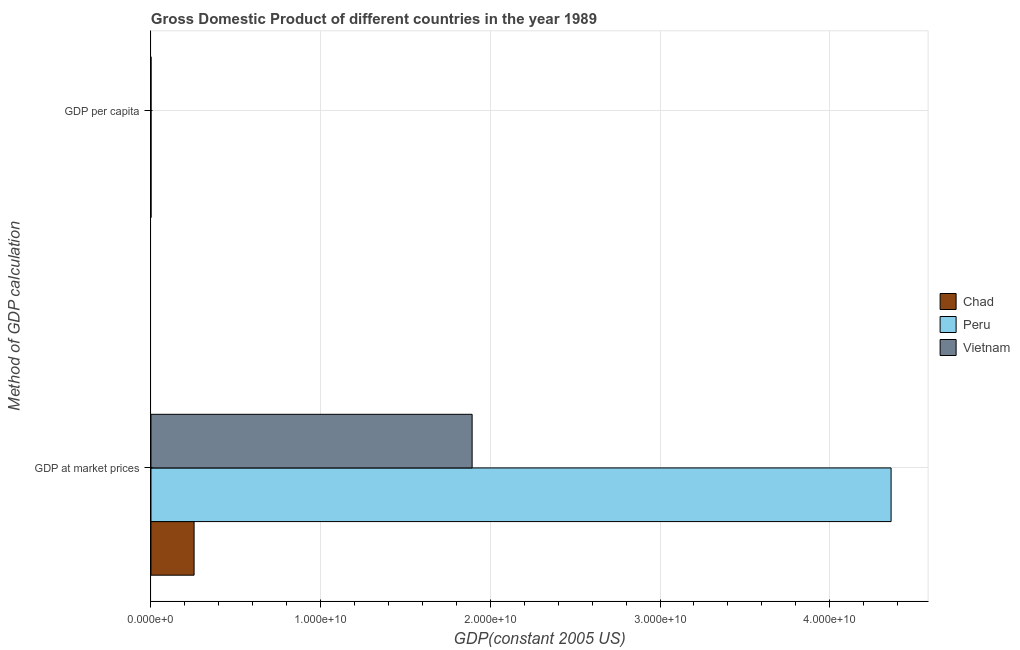How many different coloured bars are there?
Your answer should be compact. 3. Are the number of bars per tick equal to the number of legend labels?
Provide a short and direct response. Yes. What is the label of the 2nd group of bars from the top?
Offer a very short reply. GDP at market prices. What is the gdp per capita in Peru?
Your answer should be very brief. 2041.08. Across all countries, what is the maximum gdp per capita?
Offer a terse response. 2041.08. Across all countries, what is the minimum gdp at market prices?
Keep it short and to the point. 2.54e+09. In which country was the gdp per capita maximum?
Keep it short and to the point. Peru. In which country was the gdp per capita minimum?
Offer a very short reply. Vietnam. What is the total gdp at market prices in the graph?
Your answer should be compact. 6.51e+1. What is the difference between the gdp per capita in Chad and that in Vietnam?
Provide a short and direct response. 148.32. What is the difference between the gdp at market prices in Chad and the gdp per capita in Peru?
Provide a succinct answer. 2.54e+09. What is the average gdp at market prices per country?
Ensure brevity in your answer.  2.17e+1. What is the difference between the gdp per capita and gdp at market prices in Chad?
Provide a short and direct response. -2.54e+09. What is the ratio of the gdp per capita in Peru to that in Vietnam?
Offer a very short reply. 6.99. Is the gdp per capita in Vietnam less than that in Chad?
Provide a succinct answer. Yes. What does the 3rd bar from the top in GDP per capita represents?
Keep it short and to the point. Chad. What does the 3rd bar from the bottom in GDP per capita represents?
Keep it short and to the point. Vietnam. How many bars are there?
Give a very brief answer. 6. How many countries are there in the graph?
Your answer should be very brief. 3. What is the difference between two consecutive major ticks on the X-axis?
Provide a short and direct response. 1.00e+1. Are the values on the major ticks of X-axis written in scientific E-notation?
Keep it short and to the point. Yes. Does the graph contain any zero values?
Keep it short and to the point. No. Does the graph contain grids?
Ensure brevity in your answer.  Yes. Where does the legend appear in the graph?
Provide a succinct answer. Center right. How many legend labels are there?
Your answer should be compact. 3. What is the title of the graph?
Your answer should be very brief. Gross Domestic Product of different countries in the year 1989. What is the label or title of the X-axis?
Offer a very short reply. GDP(constant 2005 US). What is the label or title of the Y-axis?
Provide a short and direct response. Method of GDP calculation. What is the GDP(constant 2005 US) of Chad in GDP at market prices?
Your answer should be compact. 2.54e+09. What is the GDP(constant 2005 US) in Peru in GDP at market prices?
Offer a terse response. 4.36e+1. What is the GDP(constant 2005 US) in Vietnam in GDP at market prices?
Your response must be concise. 1.89e+1. What is the GDP(constant 2005 US) of Chad in GDP per capita?
Provide a succinct answer. 440.51. What is the GDP(constant 2005 US) of Peru in GDP per capita?
Provide a short and direct response. 2041.08. What is the GDP(constant 2005 US) of Vietnam in GDP per capita?
Your answer should be compact. 292.19. Across all Method of GDP calculation, what is the maximum GDP(constant 2005 US) of Chad?
Provide a short and direct response. 2.54e+09. Across all Method of GDP calculation, what is the maximum GDP(constant 2005 US) of Peru?
Your answer should be compact. 4.36e+1. Across all Method of GDP calculation, what is the maximum GDP(constant 2005 US) of Vietnam?
Make the answer very short. 1.89e+1. Across all Method of GDP calculation, what is the minimum GDP(constant 2005 US) in Chad?
Provide a succinct answer. 440.51. Across all Method of GDP calculation, what is the minimum GDP(constant 2005 US) in Peru?
Offer a very short reply. 2041.08. Across all Method of GDP calculation, what is the minimum GDP(constant 2005 US) of Vietnam?
Make the answer very short. 292.19. What is the total GDP(constant 2005 US) of Chad in the graph?
Your response must be concise. 2.54e+09. What is the total GDP(constant 2005 US) in Peru in the graph?
Ensure brevity in your answer.  4.36e+1. What is the total GDP(constant 2005 US) of Vietnam in the graph?
Your response must be concise. 1.89e+1. What is the difference between the GDP(constant 2005 US) of Chad in GDP at market prices and that in GDP per capita?
Make the answer very short. 2.54e+09. What is the difference between the GDP(constant 2005 US) in Peru in GDP at market prices and that in GDP per capita?
Provide a short and direct response. 4.36e+1. What is the difference between the GDP(constant 2005 US) of Vietnam in GDP at market prices and that in GDP per capita?
Your answer should be compact. 1.89e+1. What is the difference between the GDP(constant 2005 US) of Chad in GDP at market prices and the GDP(constant 2005 US) of Peru in GDP per capita?
Your answer should be very brief. 2.54e+09. What is the difference between the GDP(constant 2005 US) in Chad in GDP at market prices and the GDP(constant 2005 US) in Vietnam in GDP per capita?
Your answer should be very brief. 2.54e+09. What is the difference between the GDP(constant 2005 US) in Peru in GDP at market prices and the GDP(constant 2005 US) in Vietnam in GDP per capita?
Offer a very short reply. 4.36e+1. What is the average GDP(constant 2005 US) in Chad per Method of GDP calculation?
Offer a terse response. 1.27e+09. What is the average GDP(constant 2005 US) of Peru per Method of GDP calculation?
Your answer should be compact. 2.18e+1. What is the average GDP(constant 2005 US) in Vietnam per Method of GDP calculation?
Your answer should be compact. 9.46e+09. What is the difference between the GDP(constant 2005 US) of Chad and GDP(constant 2005 US) of Peru in GDP at market prices?
Provide a short and direct response. -4.11e+1. What is the difference between the GDP(constant 2005 US) in Chad and GDP(constant 2005 US) in Vietnam in GDP at market prices?
Make the answer very short. -1.64e+1. What is the difference between the GDP(constant 2005 US) in Peru and GDP(constant 2005 US) in Vietnam in GDP at market prices?
Offer a very short reply. 2.47e+1. What is the difference between the GDP(constant 2005 US) in Chad and GDP(constant 2005 US) in Peru in GDP per capita?
Make the answer very short. -1600.57. What is the difference between the GDP(constant 2005 US) of Chad and GDP(constant 2005 US) of Vietnam in GDP per capita?
Provide a short and direct response. 148.32. What is the difference between the GDP(constant 2005 US) in Peru and GDP(constant 2005 US) in Vietnam in GDP per capita?
Your answer should be compact. 1748.89. What is the ratio of the GDP(constant 2005 US) of Chad in GDP at market prices to that in GDP per capita?
Ensure brevity in your answer.  5.77e+06. What is the ratio of the GDP(constant 2005 US) of Peru in GDP at market prices to that in GDP per capita?
Ensure brevity in your answer.  2.14e+07. What is the ratio of the GDP(constant 2005 US) in Vietnam in GDP at market prices to that in GDP per capita?
Provide a succinct answer. 6.48e+07. What is the difference between the highest and the second highest GDP(constant 2005 US) of Chad?
Offer a very short reply. 2.54e+09. What is the difference between the highest and the second highest GDP(constant 2005 US) in Peru?
Offer a terse response. 4.36e+1. What is the difference between the highest and the second highest GDP(constant 2005 US) in Vietnam?
Provide a succinct answer. 1.89e+1. What is the difference between the highest and the lowest GDP(constant 2005 US) in Chad?
Your answer should be very brief. 2.54e+09. What is the difference between the highest and the lowest GDP(constant 2005 US) of Peru?
Your response must be concise. 4.36e+1. What is the difference between the highest and the lowest GDP(constant 2005 US) of Vietnam?
Ensure brevity in your answer.  1.89e+1. 